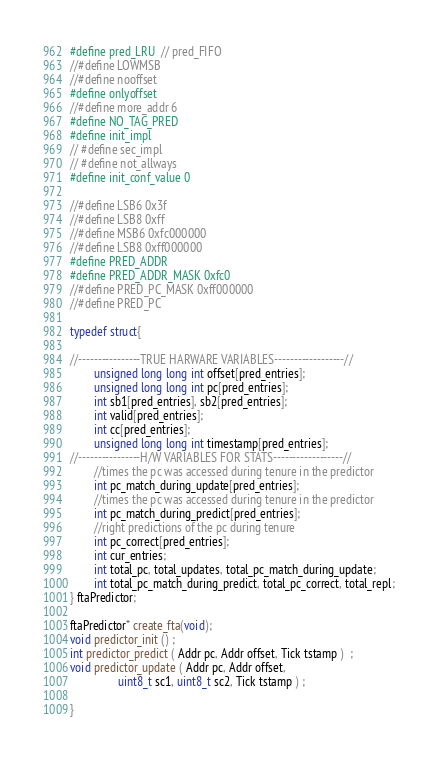<code> <loc_0><loc_0><loc_500><loc_500><_C++_>#define pred_LRU  // pred_FIFO
//#define LOWMSB
//#define nooffset
#define onlyoffset
//#define more_addr 6
#define NO_TAG_PRED
#define init_impl
// #define sec_impl
// #define not_allways
#define init_conf_value 0

//#define LSB6 0x3f
//#define LSB8 0xff
//#define MSB6 0xfc000000
//#define LSB8 0xff000000
#define PRED_ADDR
#define PRED_ADDR_MASK 0xfc0
//#define PRED_PC_MASK 0xff000000
//#define PRED_PC

typedef struct{

//----------------TRUE HARWARE VARIABLES------------------//
        unsigned long long int offset[pred_entries];
        unsigned long long int pc[pred_entries];
        int sb1[pred_entries], sb2[pred_entries];
        int valid[pred_entries];
        int cc[pred_entries];
        unsigned long long int timestamp[pred_entries];
//----------------H/W VARIABLES FOR STATS------------------//
        //times the pc was accessed during tenure in the predictor
        int pc_match_during_update[pred_entries];
        //times the pc was accessed during tenure in the predictor
        int pc_match_during_predict[pred_entries];
        //right predictions of the pc during tenure
        int pc_correct[pred_entries];
        int cur_entries;
        int total_pc, total_updates, total_pc_match_during_update;
        int total_pc_match_during_predict, total_pc_correct, total_repl;
} ftaPredictor;

ftaPredictor* create_fta(void);
void predictor_init () ;
int predictor_predict ( Addr pc, Addr offset, Tick tstamp )  ;
void predictor_update ( Addr pc, Addr offset,
                uint8_t sc1, uint8_t sc2, Tick tstamp ) ;

}
</code> 